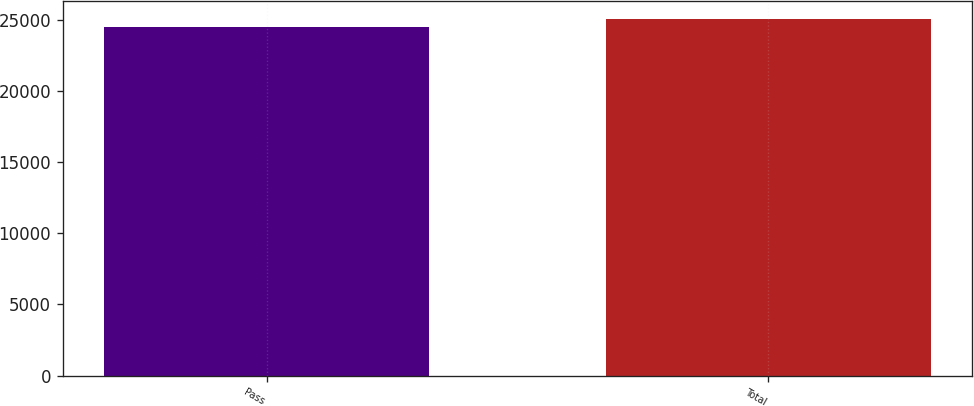<chart> <loc_0><loc_0><loc_500><loc_500><bar_chart><fcel>Pass<fcel>Total<nl><fcel>24505<fcel>25078<nl></chart> 